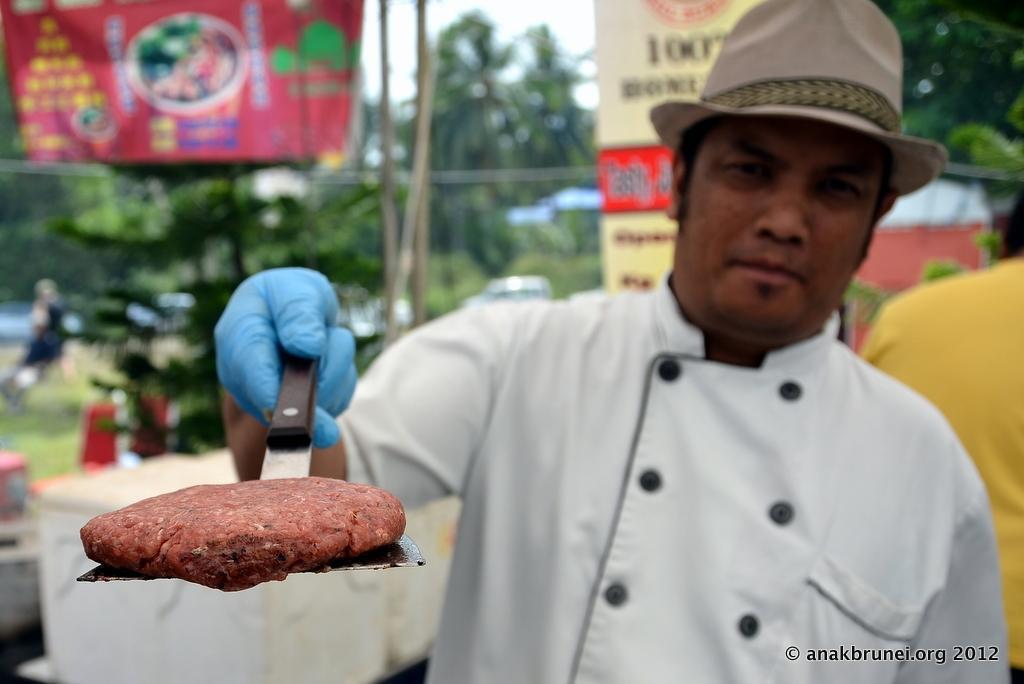Could you give a brief overview of what you see in this image? In the picture we can see a chef standing and holding a pan with a fried meat on it and the chef is with white shirt and blue color glove and hat and behind him we can see another man standing he is with yellow shirt and in the background we can see some plants and trees and sky. 